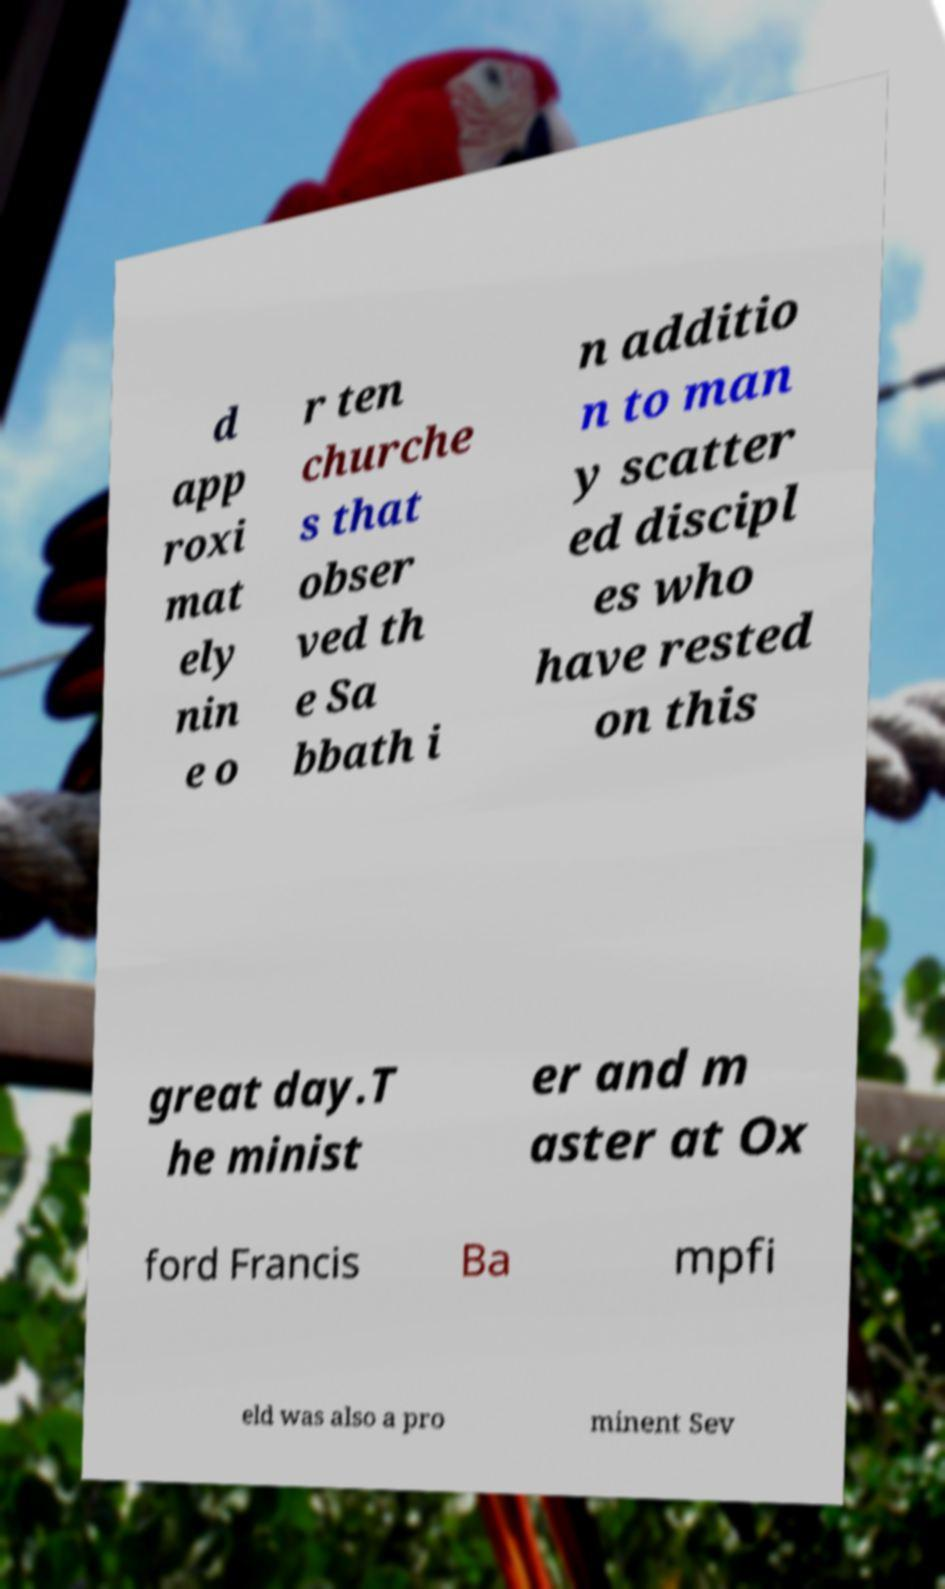Please identify and transcribe the text found in this image. d app roxi mat ely nin e o r ten churche s that obser ved th e Sa bbath i n additio n to man y scatter ed discipl es who have rested on this great day.T he minist er and m aster at Ox ford Francis Ba mpfi eld was also a pro minent Sev 